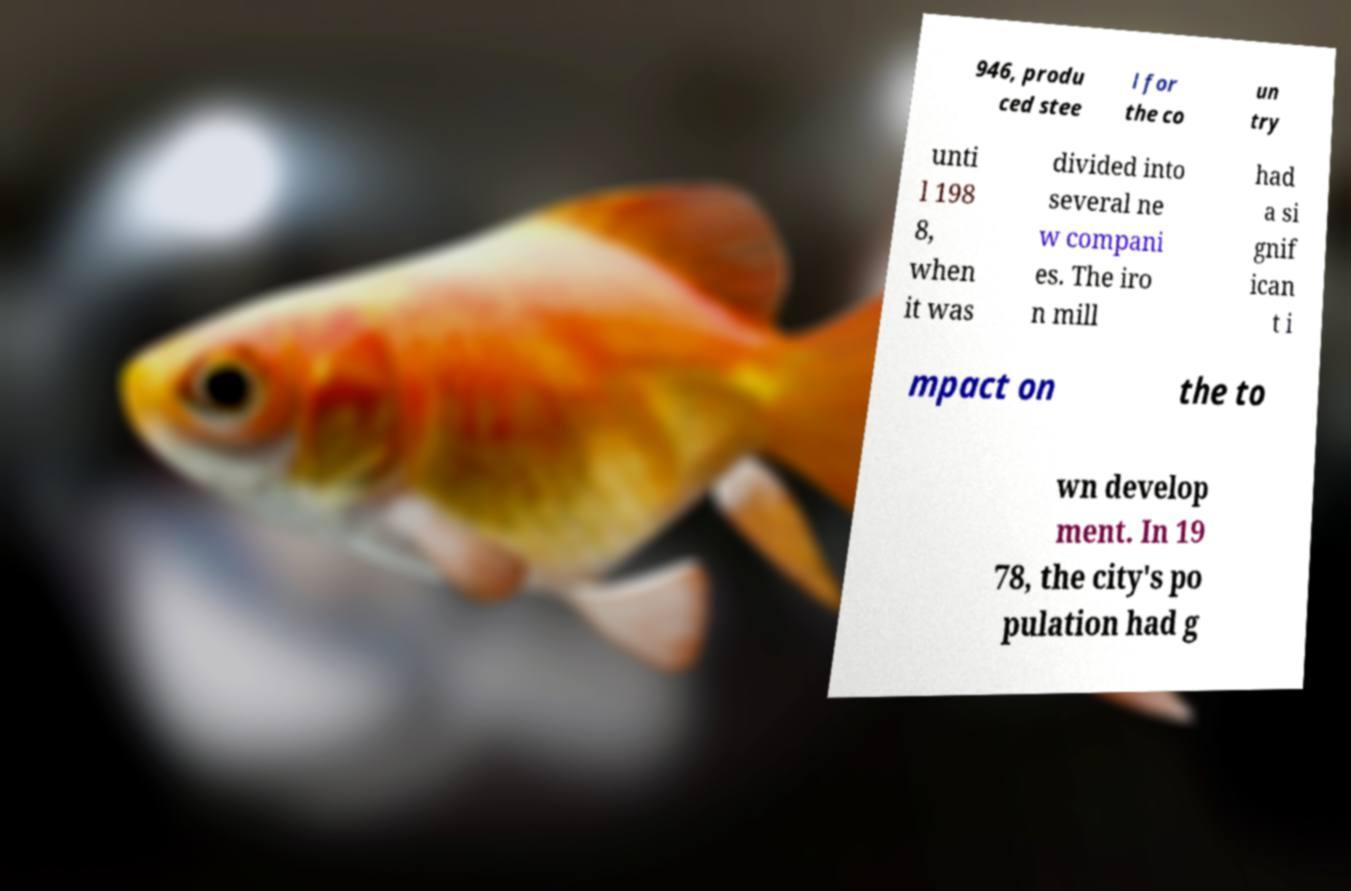I need the written content from this picture converted into text. Can you do that? 946, produ ced stee l for the co un try unti l 198 8, when it was divided into several ne w compani es. The iro n mill had a si gnif ican t i mpact on the to wn develop ment. In 19 78, the city's po pulation had g 